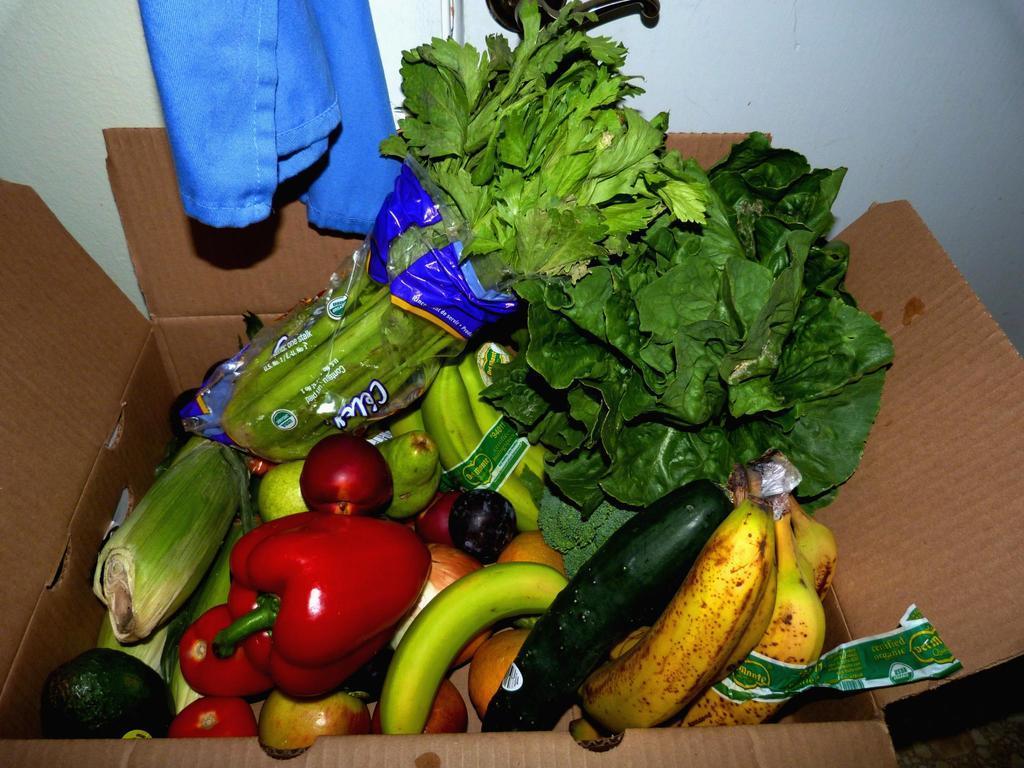Could you give a brief overview of what you see in this image? In the center of the image we can see one box. In the box, we can see different types of vegetables and fruits like bananas, leafy vegetables, tomatoes, etc. And there is a plastic cover, plastic tape and a few other objects. In the background there is a wall, cloth, black color object and a few objects. 